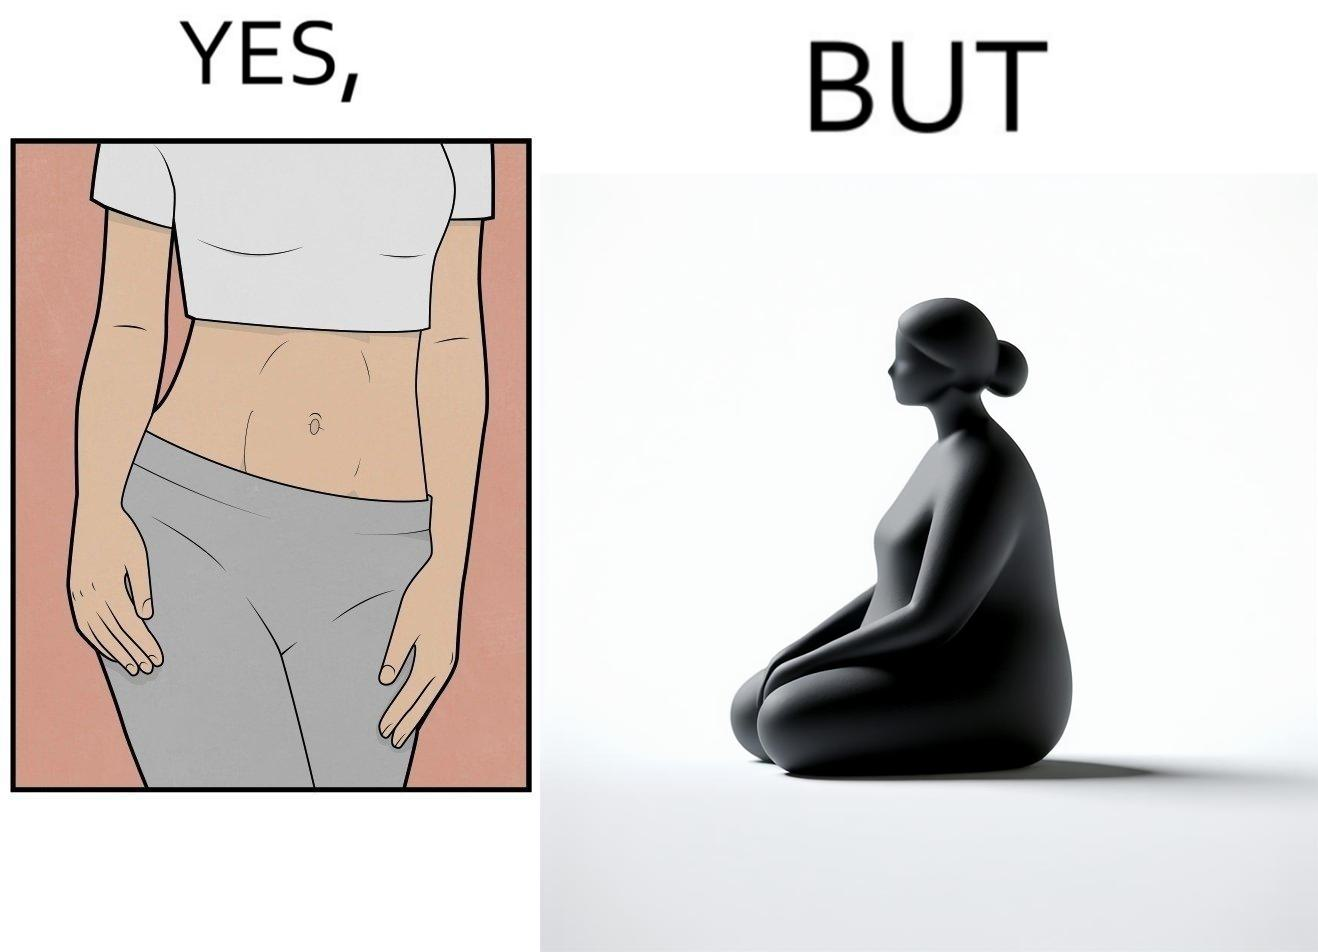What is the satirical meaning behind this image? the image is funny, as from the front, the woman is apparently slim, but she looks chubby from the side. 